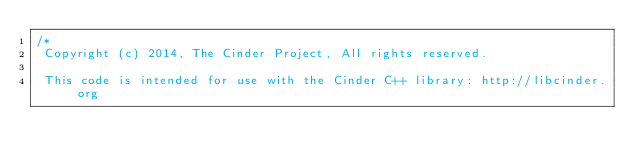<code> <loc_0><loc_0><loc_500><loc_500><_ObjectiveC_>/*
 Copyright (c) 2014, The Cinder Project, All rights reserved.
 
 This code is intended for use with the Cinder C++ library: http://libcinder.org
 </code> 